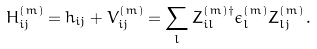Convert formula to latex. <formula><loc_0><loc_0><loc_500><loc_500>H _ { i j } ^ { ( m ) } = h _ { i j } + V _ { i j } ^ { ( m ) } = \sum _ { l } Z _ { i l } ^ { ( m ) \dagger } \epsilon _ { l } ^ { ( m ) } Z _ { l j } ^ { ( m ) } \, .</formula> 